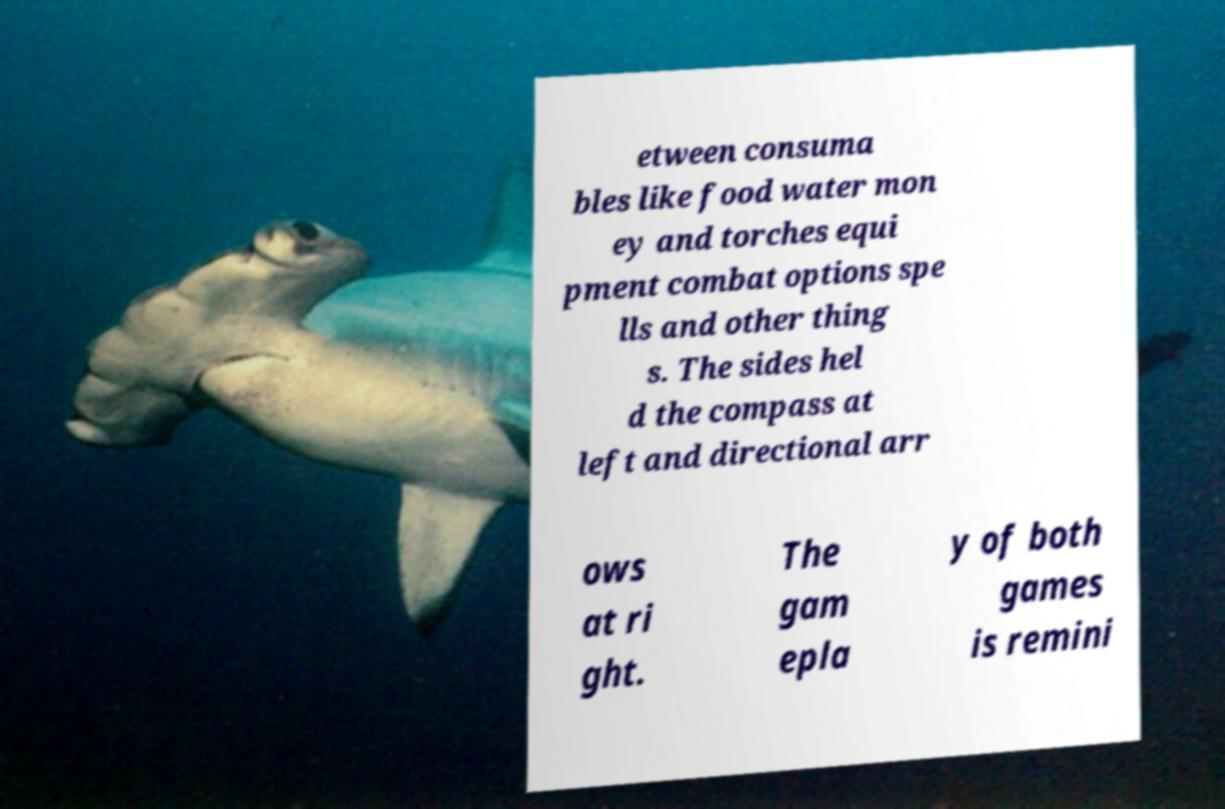Please identify and transcribe the text found in this image. etween consuma bles like food water mon ey and torches equi pment combat options spe lls and other thing s. The sides hel d the compass at left and directional arr ows at ri ght. The gam epla y of both games is remini 